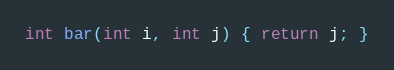Convert code to text. <code><loc_0><loc_0><loc_500><loc_500><_C++_>int bar(int i, int j) { return j; }
</code> 